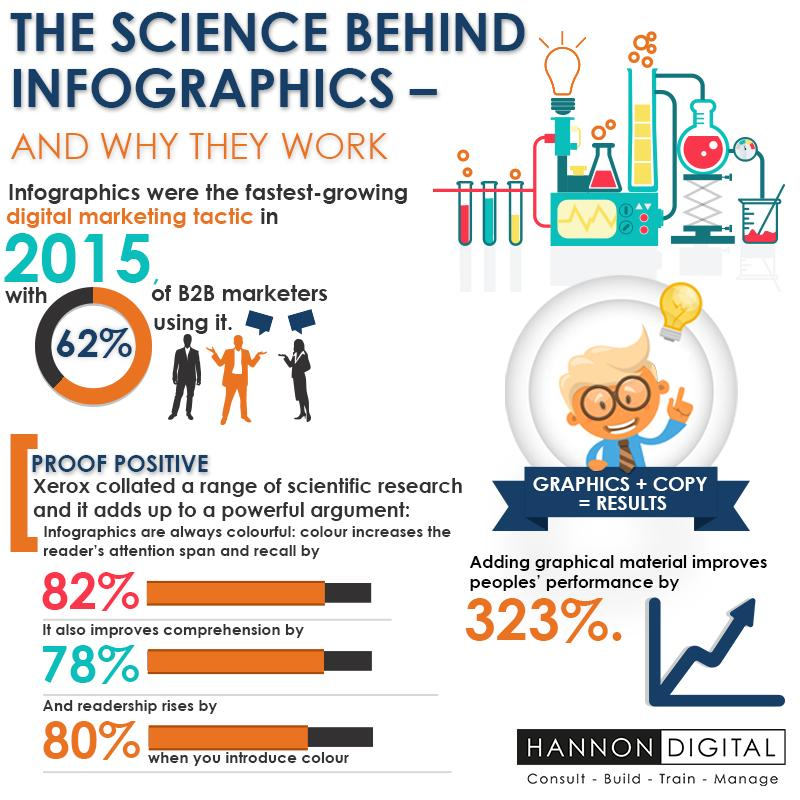Draw attention to some important aspects in this diagram. Colorful infographics can engage audiences by a significant percentage, with 82% being the most effective. According to a survey of B2B marketers, 38% do not use digital marketing. 